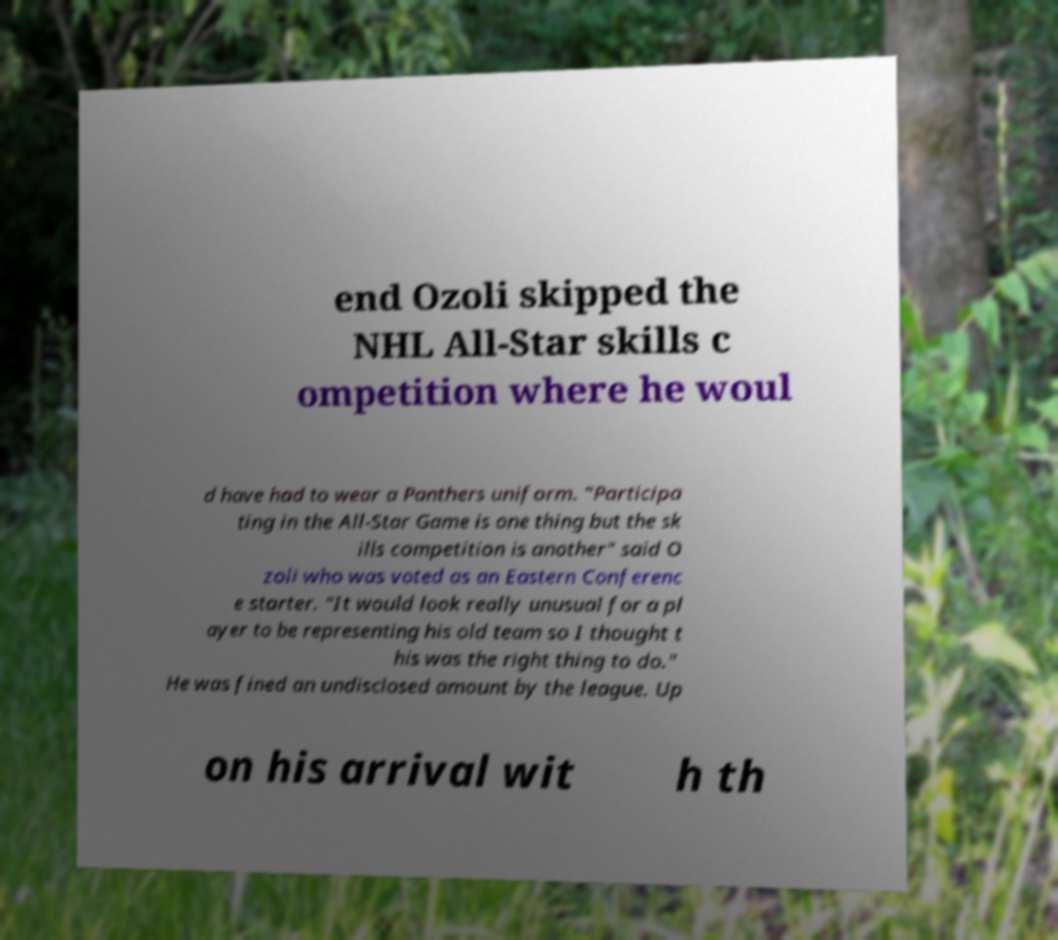Could you assist in decoding the text presented in this image and type it out clearly? end Ozoli skipped the NHL All-Star skills c ompetition where he woul d have had to wear a Panthers uniform. "Participa ting in the All-Star Game is one thing but the sk ills competition is another" said O zoli who was voted as an Eastern Conferenc e starter. "It would look really unusual for a pl ayer to be representing his old team so I thought t his was the right thing to do." He was fined an undisclosed amount by the league. Up on his arrival wit h th 